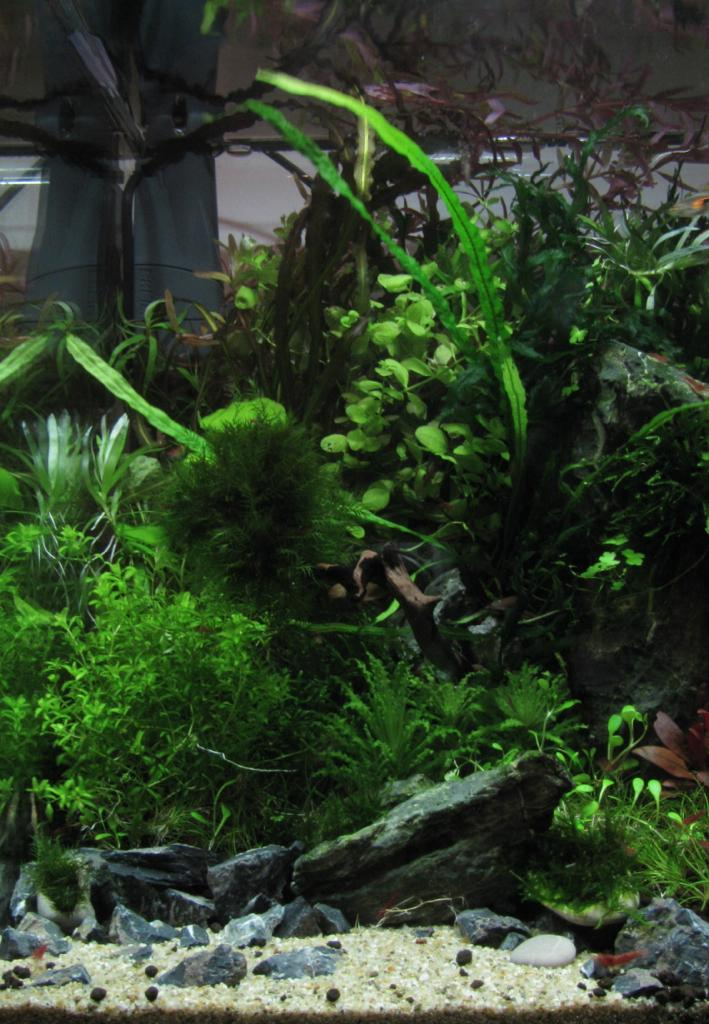What type of living organisms can be seen in the image? Plants can be seen in the image. What other objects are present in the image besides plants? There are rocks in the image. Can you tell me how many farmers are tending to the plants in the image? There is no farmer present in the image. Is there an owl perched on any of the rocks in the image? There is no owl present in the image. 